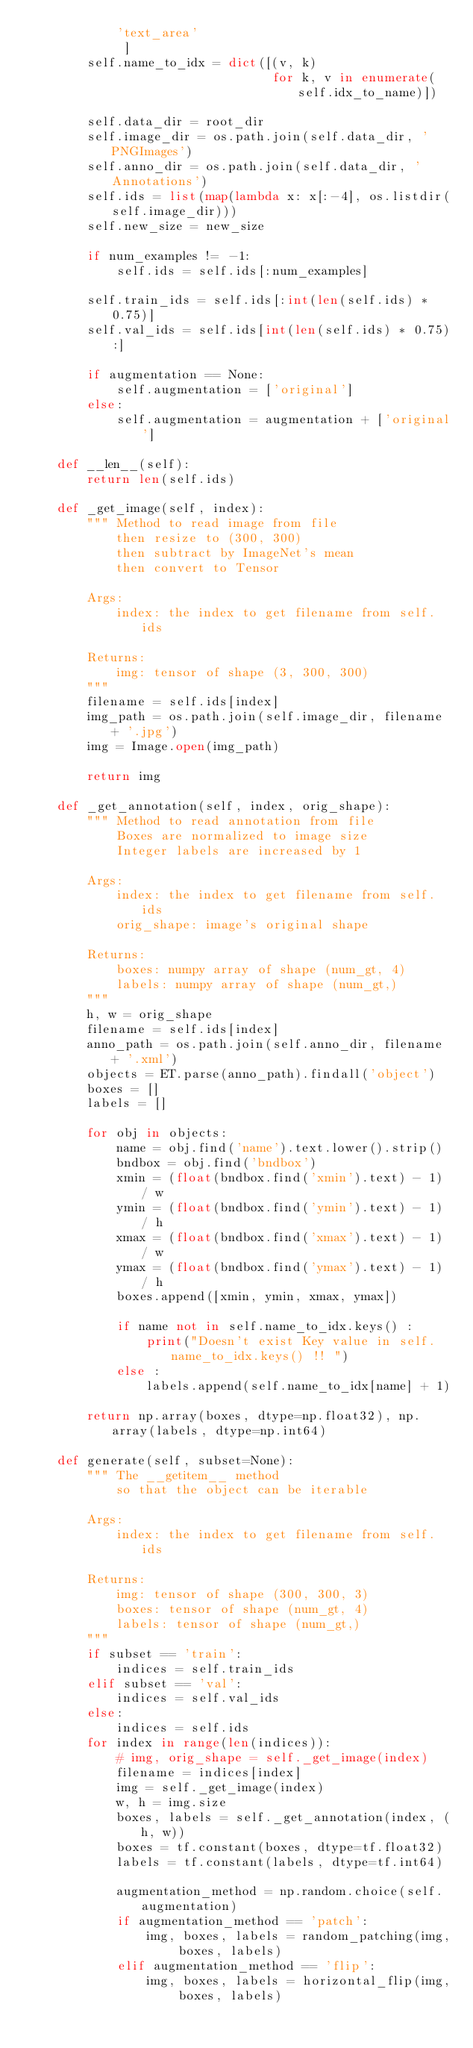Convert code to text. <code><loc_0><loc_0><loc_500><loc_500><_Python_>            'text_area'
             ]
        self.name_to_idx = dict([(v, k)
                                 for k, v in enumerate(self.idx_to_name)])

        self.data_dir = root_dir
        self.image_dir = os.path.join(self.data_dir, 'PNGImages')
        self.anno_dir = os.path.join(self.data_dir, 'Annotations')
        self.ids = list(map(lambda x: x[:-4], os.listdir(self.image_dir)))
        self.new_size = new_size

        if num_examples != -1:
            self.ids = self.ids[:num_examples]

        self.train_ids = self.ids[:int(len(self.ids) * 0.75)]
        self.val_ids = self.ids[int(len(self.ids) * 0.75):]

        if augmentation == None:
            self.augmentation = ['original']
        else:
            self.augmentation = augmentation + ['original']

    def __len__(self):
        return len(self.ids)

    def _get_image(self, index):
        """ Method to read image from file
            then resize to (300, 300)
            then subtract by ImageNet's mean
            then convert to Tensor

        Args:
            index: the index to get filename from self.ids

        Returns:
            img: tensor of shape (3, 300, 300)
        """
        filename = self.ids[index]
        img_path = os.path.join(self.image_dir, filename + '.jpg')
        img = Image.open(img_path)

        return img

    def _get_annotation(self, index, orig_shape):
        """ Method to read annotation from file
            Boxes are normalized to image size
            Integer labels are increased by 1

        Args:
            index: the index to get filename from self.ids
            orig_shape: image's original shape

        Returns:
            boxes: numpy array of shape (num_gt, 4)
            labels: numpy array of shape (num_gt,)
        """
        h, w = orig_shape
        filename = self.ids[index]
        anno_path = os.path.join(self.anno_dir, filename + '.xml')
        objects = ET.parse(anno_path).findall('object')
        boxes = []
        labels = []

        for obj in objects:
            name = obj.find('name').text.lower().strip()
            bndbox = obj.find('bndbox')
            xmin = (float(bndbox.find('xmin').text) - 1) / w
            ymin = (float(bndbox.find('ymin').text) - 1) / h
            xmax = (float(bndbox.find('xmax').text) - 1) / w
            ymax = (float(bndbox.find('ymax').text) - 1) / h
            boxes.append([xmin, ymin, xmax, ymax])

            if name not in self.name_to_idx.keys() :
                print("Doesn't exist Key value in self.name_to_idx.keys() !! ")
            else :
                labels.append(self.name_to_idx[name] + 1)

        return np.array(boxes, dtype=np.float32), np.array(labels, dtype=np.int64)

    def generate(self, subset=None):
        """ The __getitem__ method
            so that the object can be iterable

        Args:
            index: the index to get filename from self.ids

        Returns:
            img: tensor of shape (300, 300, 3)
            boxes: tensor of shape (num_gt, 4)
            labels: tensor of shape (num_gt,)
        """
        if subset == 'train':
            indices = self.train_ids
        elif subset == 'val':
            indices = self.val_ids
        else:
            indices = self.ids
        for index in range(len(indices)):
            # img, orig_shape = self._get_image(index)
            filename = indices[index]
            img = self._get_image(index)
            w, h = img.size
            boxes, labels = self._get_annotation(index, (h, w))
            boxes = tf.constant(boxes, dtype=tf.float32)
            labels = tf.constant(labels, dtype=tf.int64)

            augmentation_method = np.random.choice(self.augmentation)
            if augmentation_method == 'patch':
                img, boxes, labels = random_patching(img, boxes, labels)
            elif augmentation_method == 'flip':
                img, boxes, labels = horizontal_flip(img, boxes, labels)
</code> 